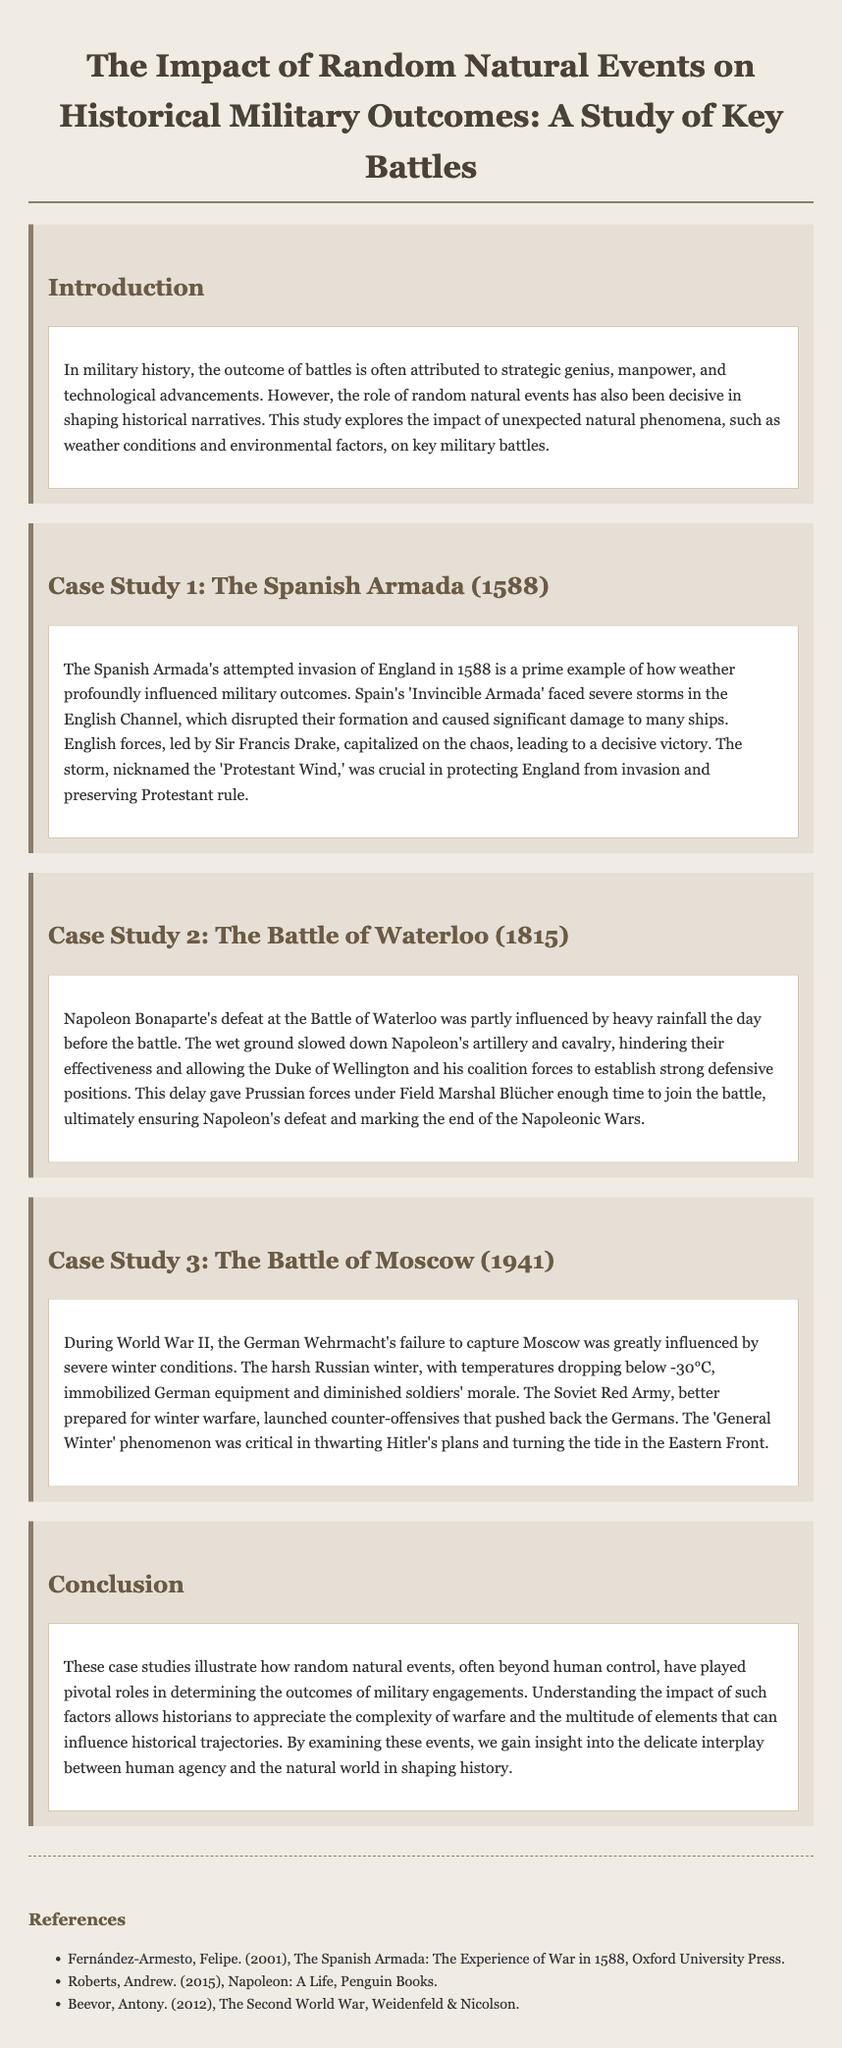What was the year of the Spanish Armada? The document states that the Spanish Armada attempted an invasion in the year 1588.
Answer: 1588 Which natural phenomenon helped England during the Spanish Armada? The document mentions the severe storms faced by the Armada, specifically referred to as the 'Protestant Wind'.
Answer: Protestant Wind What battle marked the end of the Napoleonic Wars? The text indicates that Napoleon's defeat at the Battle of Waterloo marked the end of the Napoleonic Wars.
Answer: Battle of Waterloo What factor hindered Napoleon's artillery effectiveness at Waterloo? The document notes that heavy rainfall the day before the battle resulted in wet ground, slowing down Napoleon's artillery.
Answer: Heavy rainfall What was the key environmental challenge for the German Wehrmacht in 1941? The text explains that severe winter conditions, with temperatures dropping below -30°C, posed significant challenges.
Answer: Severe winter conditions Who led the English forces against the Spanish Armada? The document states that Sir Francis Drake led the English forces during this conflict.
Answer: Sir Francis Drake Which event allowed Prussian forces to join the battle at Waterloo? The delay caused by heavy rainfall allowed Prussian forces under Field Marshal Blücher enough time to join the battle.
Answer: Heavy rainfall What cold weather phenomenon is mentioned as critical in the Battle of Moscow? The document refers to the 'General Winter' phenomenon as critical during the campaign.
Answer: General Winter What theme is explored in the conclusion of the document? The conclusion emphasizes the interplay between human agency and the natural world in shaping historical outcomes.
Answer: Interplay between human agency and natural world 